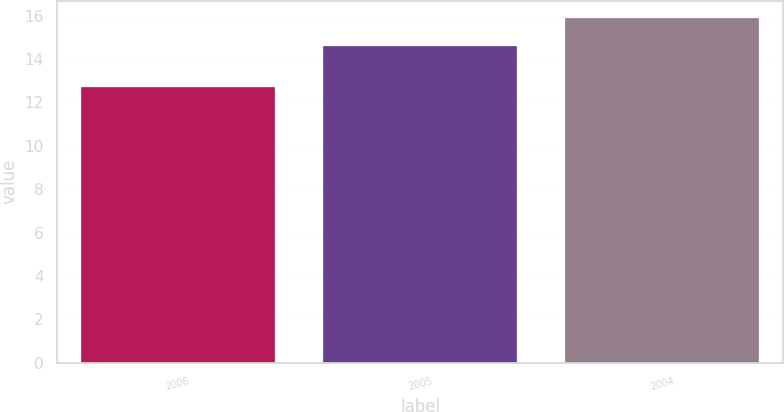Convert chart to OTSL. <chart><loc_0><loc_0><loc_500><loc_500><bar_chart><fcel>2006<fcel>2005<fcel>2004<nl><fcel>12.7<fcel>14.6<fcel>15.9<nl></chart> 